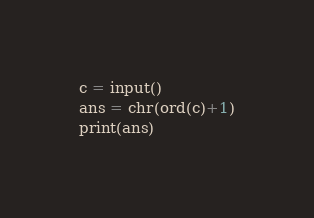Convert code to text. <code><loc_0><loc_0><loc_500><loc_500><_Python_>c = input()
ans = chr(ord(c)+1)
print(ans)</code> 